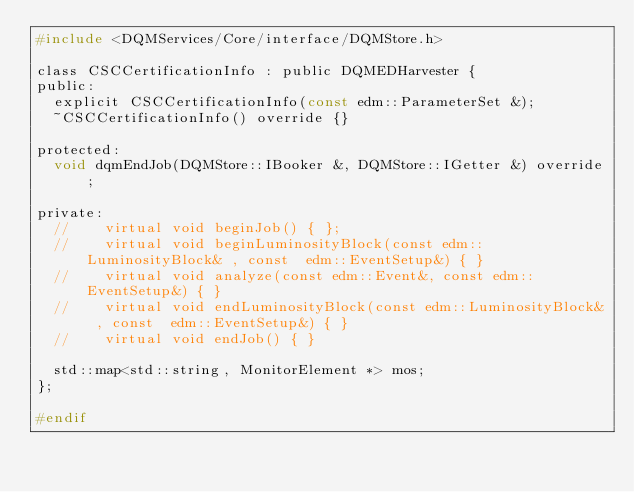<code> <loc_0><loc_0><loc_500><loc_500><_C_>#include <DQMServices/Core/interface/DQMStore.h>

class CSCCertificationInfo : public DQMEDHarvester {
public:
  explicit CSCCertificationInfo(const edm::ParameterSet &);
  ~CSCCertificationInfo() override {}

protected:
  void dqmEndJob(DQMStore::IBooker &, DQMStore::IGetter &) override;

private:
  //    virtual void beginJob() { };
  //    virtual void beginLuminosityBlock(const edm::LuminosityBlock& , const  edm::EventSetup&) { }
  //    virtual void analyze(const edm::Event&, const edm::EventSetup&) { }
  //    virtual void endLuminosityBlock(const edm::LuminosityBlock& , const  edm::EventSetup&) { }
  //    virtual void endJob() { }

  std::map<std::string, MonitorElement *> mos;
};

#endif
</code> 